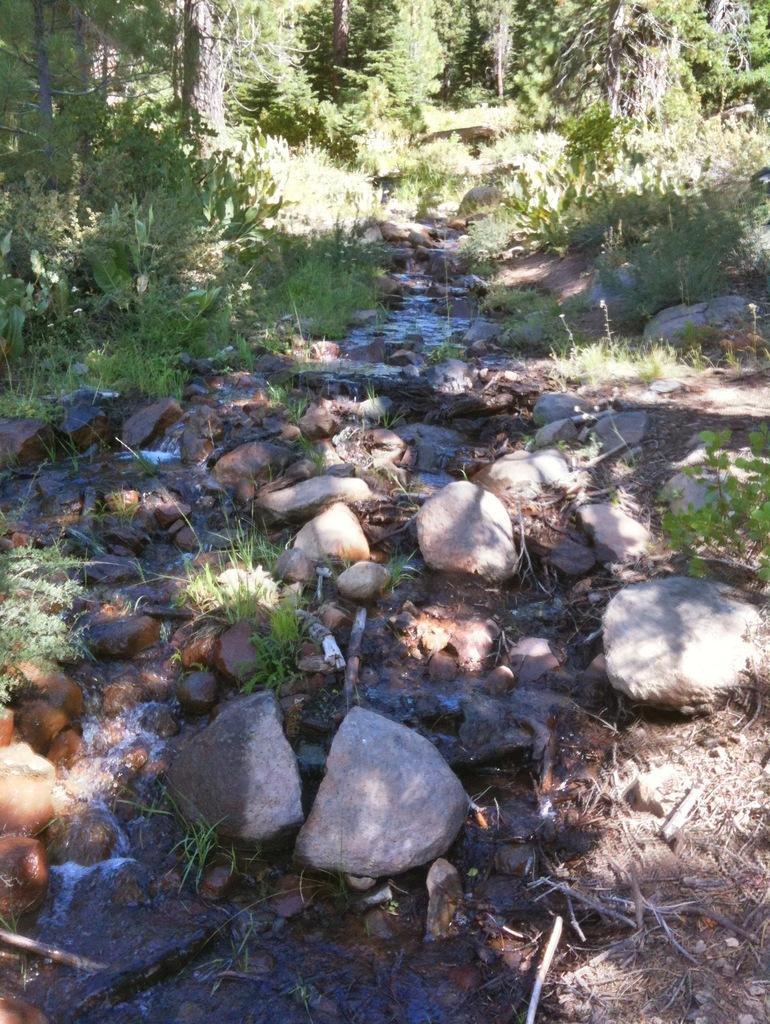Can you describe this image briefly? In this picture I can see the water in the middle and also there are stones, at the top there are trees. 